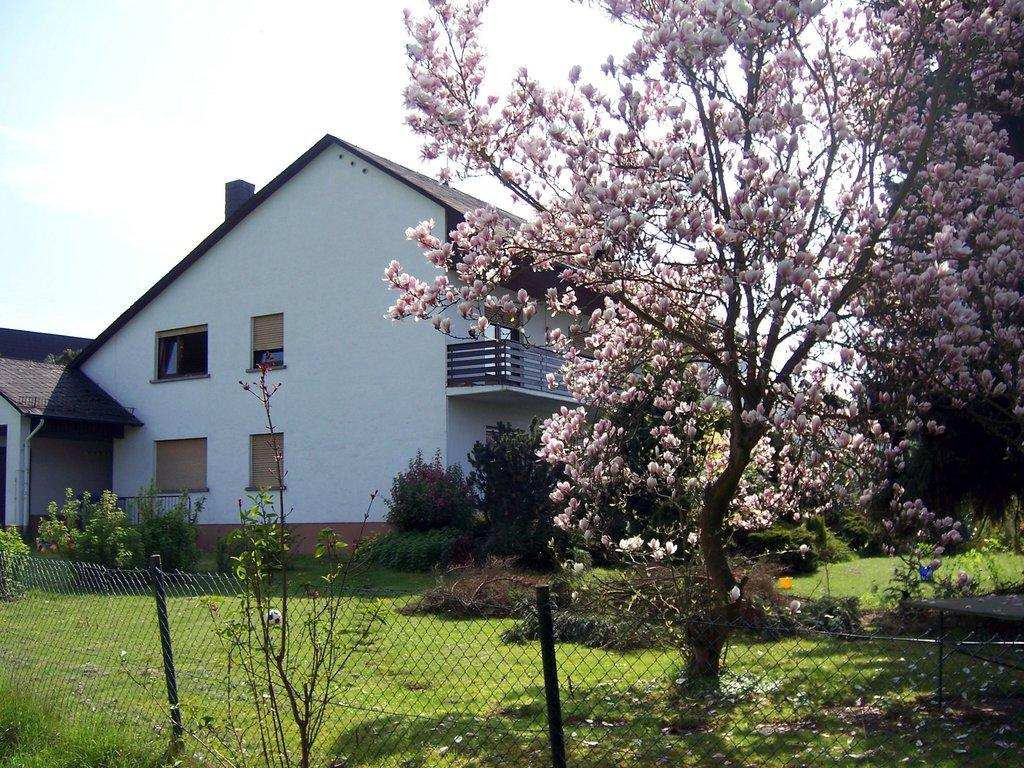What type of flora is present in the image? There are flowers in the image. Can you describe the color of the flowers? The flowers are in lite pink color. What can be seen in the background of the image? There are trees in the background of the image. What is the color of the trees? The trees are in green color. What type of structure is visible in the image? There is fencing in the image. What type of building is present in the image? There is a building in the image. Can you describe the color of the building? The building is in white color. What is the color of the sky in the image? The sky is in white color. How many pages of the book can be seen in the image? There is no book or pages present in the image; it features flowers, trees, fencing, a building, and a white sky. 